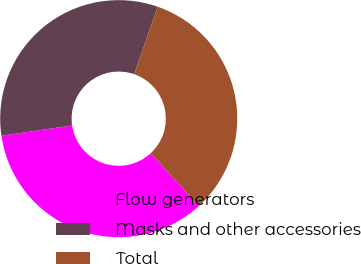<chart> <loc_0><loc_0><loc_500><loc_500><pie_chart><fcel>Flow generators<fcel>Masks and other accessories<fcel>Total<nl><fcel>34.55%<fcel>32.63%<fcel>32.82%<nl></chart> 